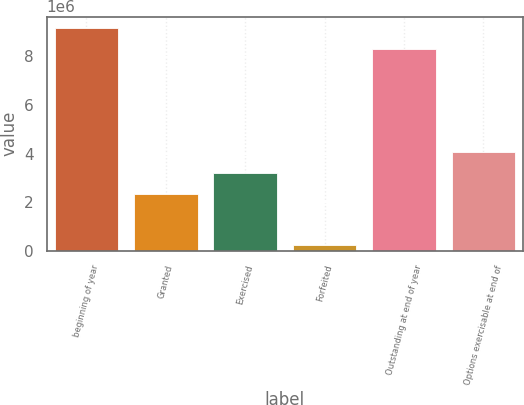<chart> <loc_0><loc_0><loc_500><loc_500><bar_chart><fcel>beginning of year<fcel>Granted<fcel>Exercised<fcel>Forfeited<fcel>Outstanding at end of year<fcel>Options exercisable at end of<nl><fcel>9.16121e+06<fcel>2.33665e+06<fcel>3.19645e+06<fcel>234708<fcel>8.30141e+06<fcel>4.05625e+06<nl></chart> 